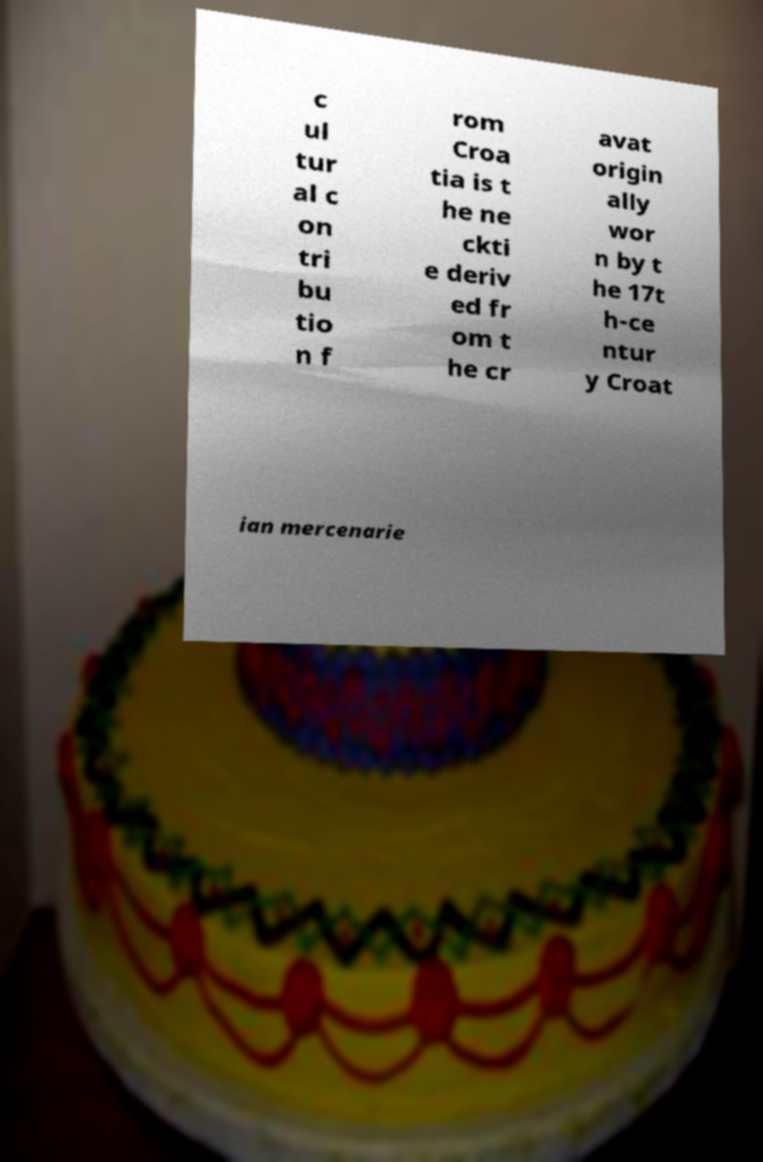For documentation purposes, I need the text within this image transcribed. Could you provide that? c ul tur al c on tri bu tio n f rom Croa tia is t he ne ckti e deriv ed fr om t he cr avat origin ally wor n by t he 17t h-ce ntur y Croat ian mercenarie 